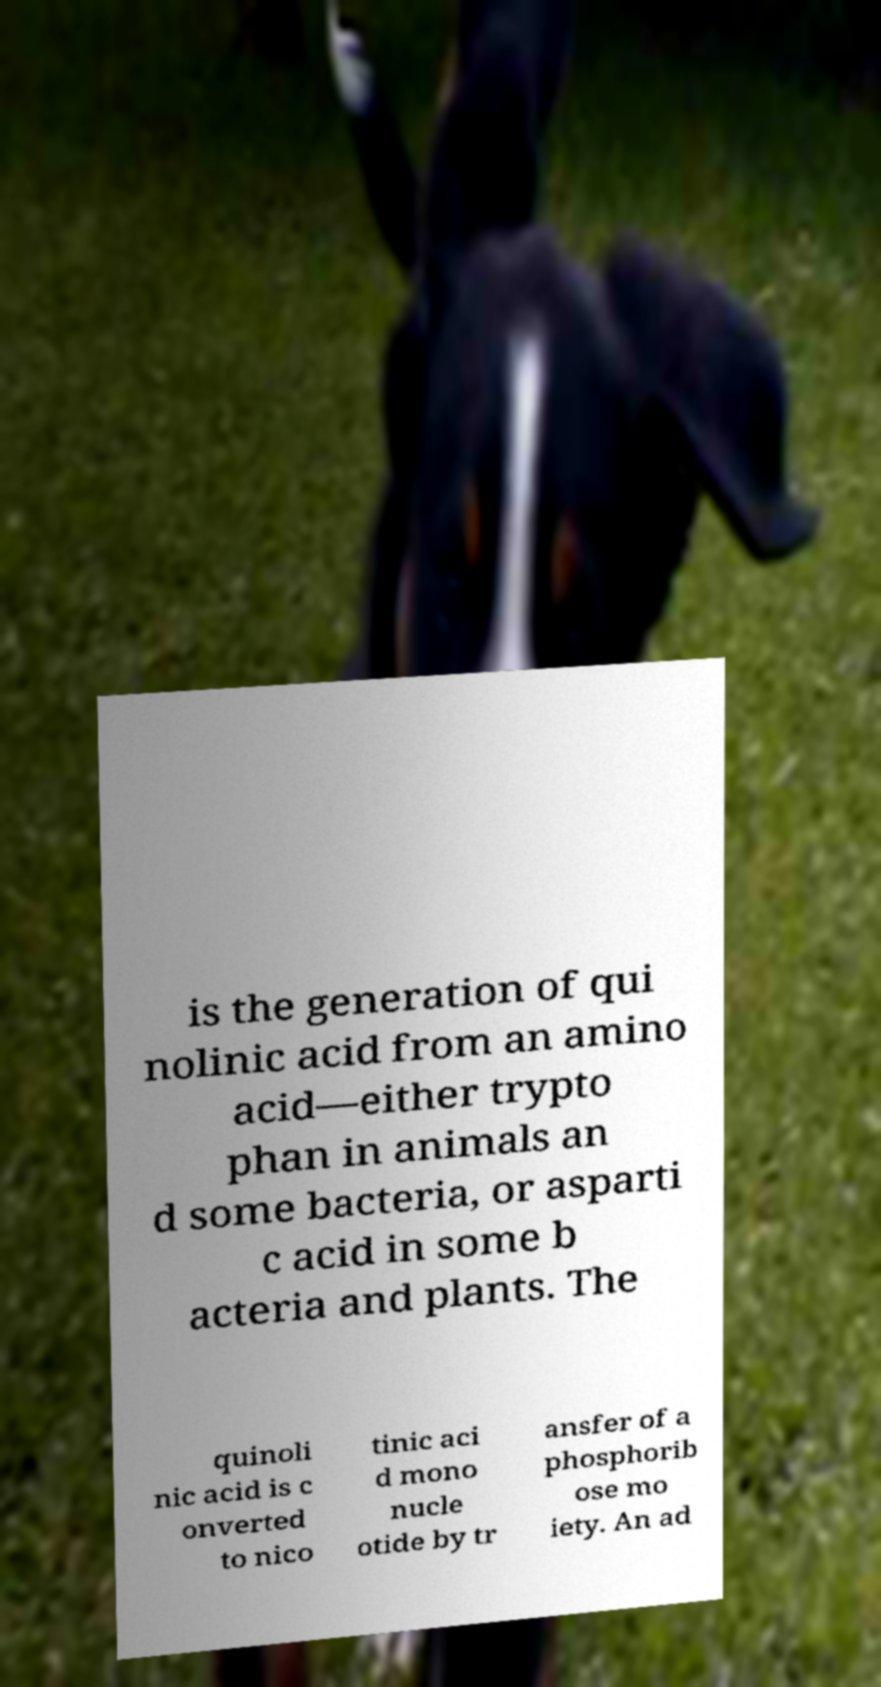I need the written content from this picture converted into text. Can you do that? is the generation of qui nolinic acid from an amino acid—either trypto phan in animals an d some bacteria, or asparti c acid in some b acteria and plants. The quinoli nic acid is c onverted to nico tinic aci d mono nucle otide by tr ansfer of a phosphorib ose mo iety. An ad 